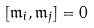<formula> <loc_0><loc_0><loc_500><loc_500>[ { \mathfrak { m } } _ { i } , { \mathfrak { m } } _ { j } ] = 0</formula> 